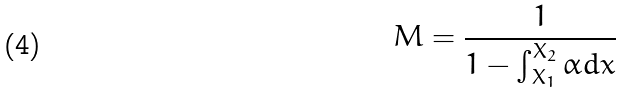Convert formula to latex. <formula><loc_0><loc_0><loc_500><loc_500>M = \frac { 1 } { 1 - \int _ { X _ { 1 } } ^ { X _ { 2 } } \alpha d x }</formula> 